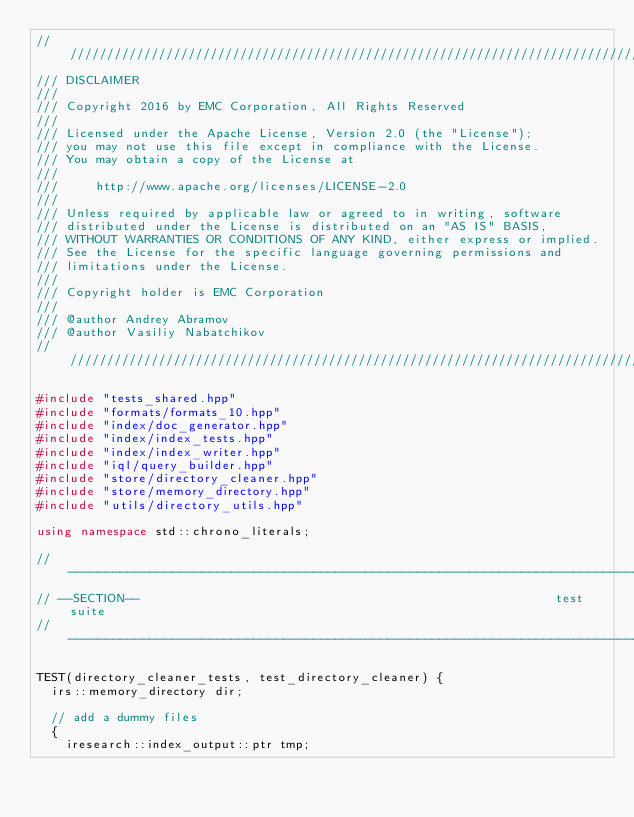Convert code to text. <code><loc_0><loc_0><loc_500><loc_500><_C++_>////////////////////////////////////////////////////////////////////////////////
/// DISCLAIMER
///
/// Copyright 2016 by EMC Corporation, All Rights Reserved
///
/// Licensed under the Apache License, Version 2.0 (the "License");
/// you may not use this file except in compliance with the License.
/// You may obtain a copy of the License at
///
///     http://www.apache.org/licenses/LICENSE-2.0
///
/// Unless required by applicable law or agreed to in writing, software
/// distributed under the License is distributed on an "AS IS" BASIS,
/// WITHOUT WARRANTIES OR CONDITIONS OF ANY KIND, either express or implied.
/// See the License for the specific language governing permissions and
/// limitations under the License.
///
/// Copyright holder is EMC Corporation
///
/// @author Andrey Abramov
/// @author Vasiliy Nabatchikov
////////////////////////////////////////////////////////////////////////////////

#include "tests_shared.hpp"
#include "formats/formats_10.hpp"
#include "index/doc_generator.hpp"
#include "index/index_tests.hpp"
#include "index/index_writer.hpp"
#include "iql/query_builder.hpp"
#include "store/directory_cleaner.hpp"
#include "store/memory_directory.hpp"
#include "utils/directory_utils.hpp"

using namespace std::chrono_literals;

// -----------------------------------------------------------------------------
// --SECTION--                                                        test suite
// -----------------------------------------------------------------------------

TEST(directory_cleaner_tests, test_directory_cleaner) {
  irs::memory_directory dir;

  // add a dummy files
  {
    iresearch::index_output::ptr tmp;</code> 